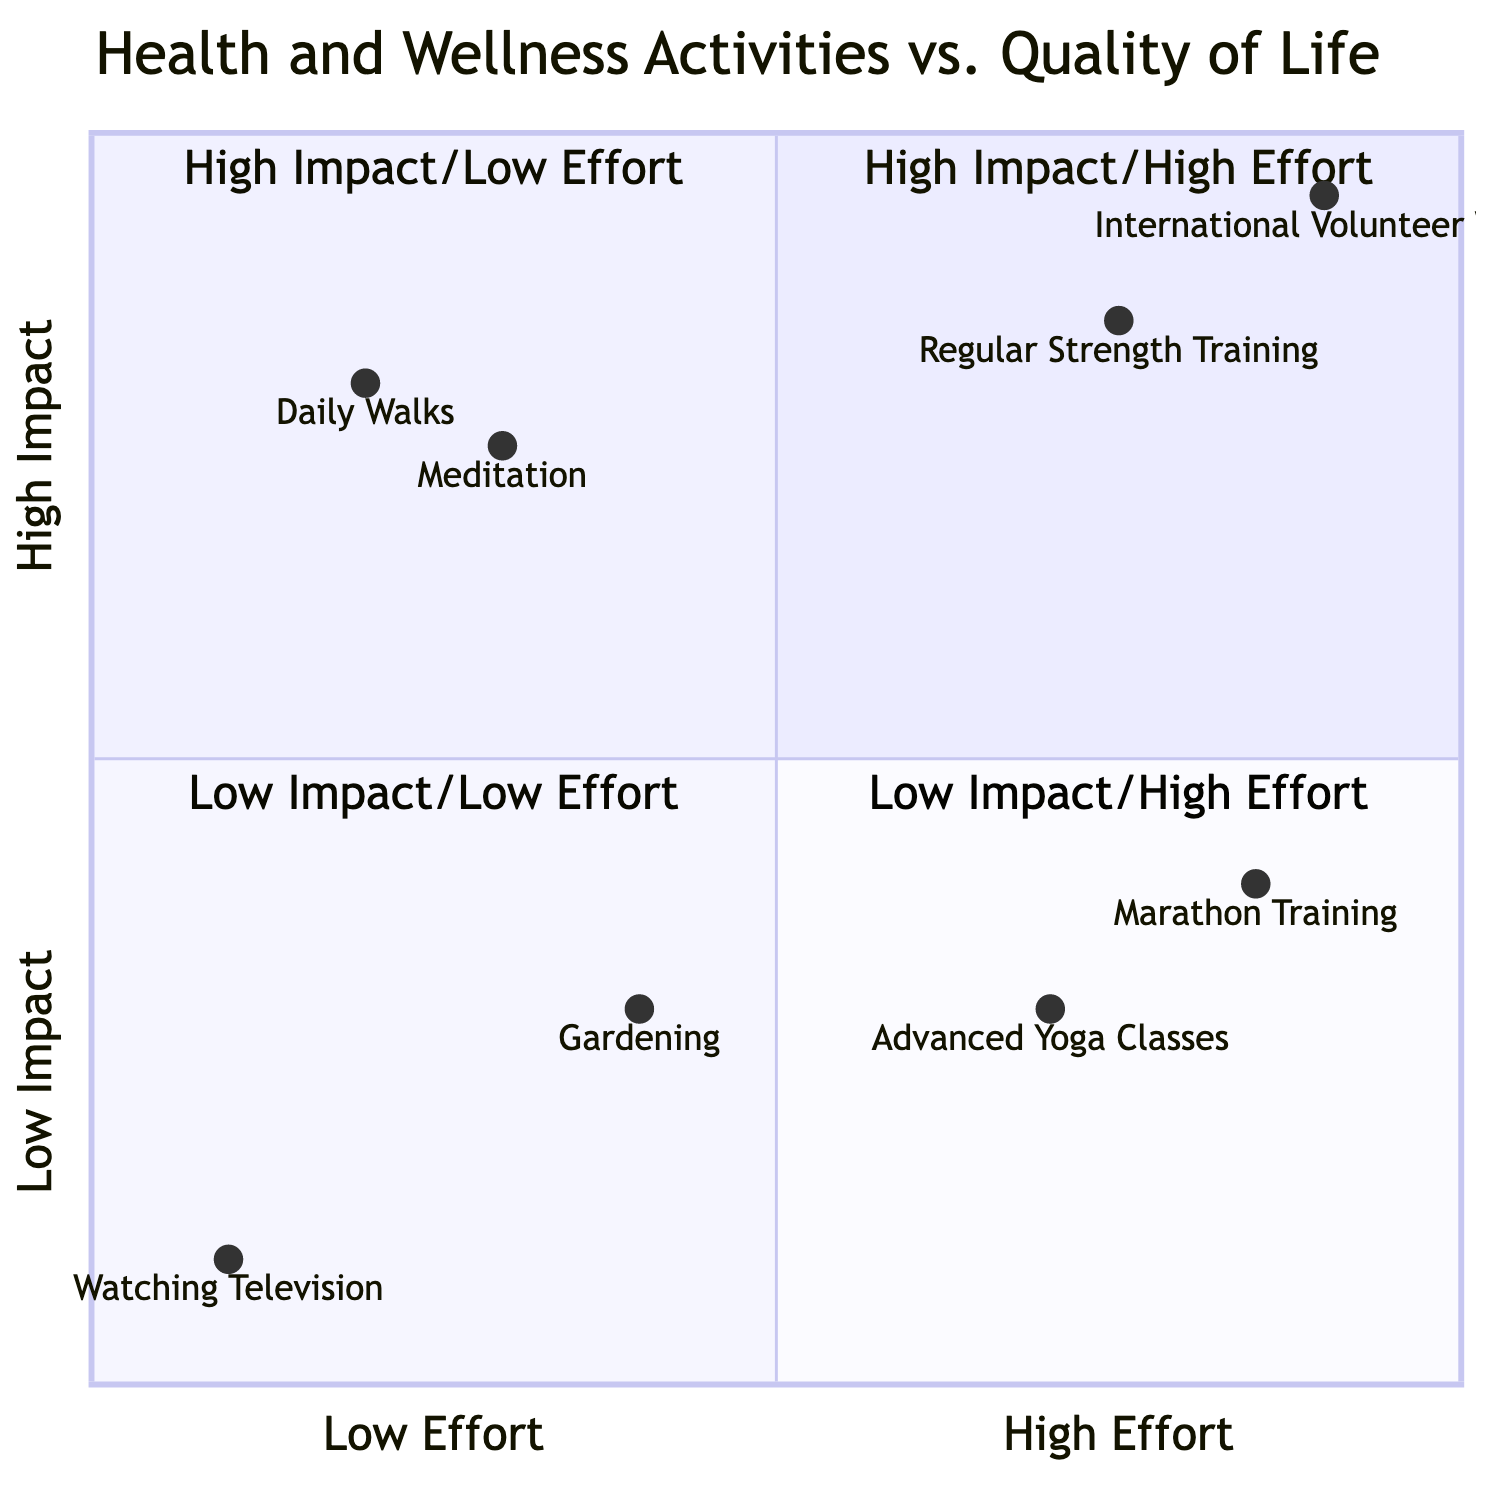What activities are categorized in the High Impact/High Effort quadrant? The diagram lists "Regular Strength Training" and "International Volunteer Work" in the High Impact/High Effort quadrant, which are both activities that require a considerable amount of effort and also have a significant positive impact on health and well-being.
Answer: Regular Strength Training, International Volunteer Work Which activity has the highest impact and lowest effort? The diagram specifies that "International Volunteer Work" has a high impact and is low effort, indicating that this activity can greatly enhance one's quality of life while not requiring extensive effort compared to others.
Answer: International Volunteer Work How many activities are depicted in the Low Impact/High Effort quadrant? By examining the diagram, only two activities, "Marathon Training" and "Advanced Yoga Classes," are present in the Low Impact/High Effort quadrant, totaling two activities.
Answer: 2 Which activity associated with the High Impact/Low Effort quadrant focuses on mental health? The diagram indicates that "Meditation" is included in the High Impact/Low Effort quadrant and describes its purpose as practicing mindfulness for stress reduction, focusing specifically on mental health improvement.
Answer: Meditation What is the primary activity for relaxation found in the Low Impact/Low Effort quadrant? The diagram shows "Watching Television" as the primary activity categorized in the Low Impact/Low Effort quadrant, identified as a leisure activity intended for relaxation and unwinding.
Answer: Watching Television Which quadrant contains the most physically demanding activities? The High Impact/High Effort quadrant holds the most physically demanding activities, specifically "Regular Strength Training" and "Marathon Training," which require significant physical exertion.
Answer: High Impact/High Effort What trend do you notice regarding effort and impact across the quadrants? Assessing the quadrants, it appears that as the effort increases from Low to High, there is a corresponding increase in impact from Low to High, indicating a positive correlation between effort and the resulting impact on health and wellness activities.
Answer: Positive correlation Which activity requires the least effort according to the diagram? "Watching Television" is noted as requiring the least effort in the Low Impact/Low Effort quadrant, emphasizing minimal physical activity and engagement.
Answer: Watching Television 